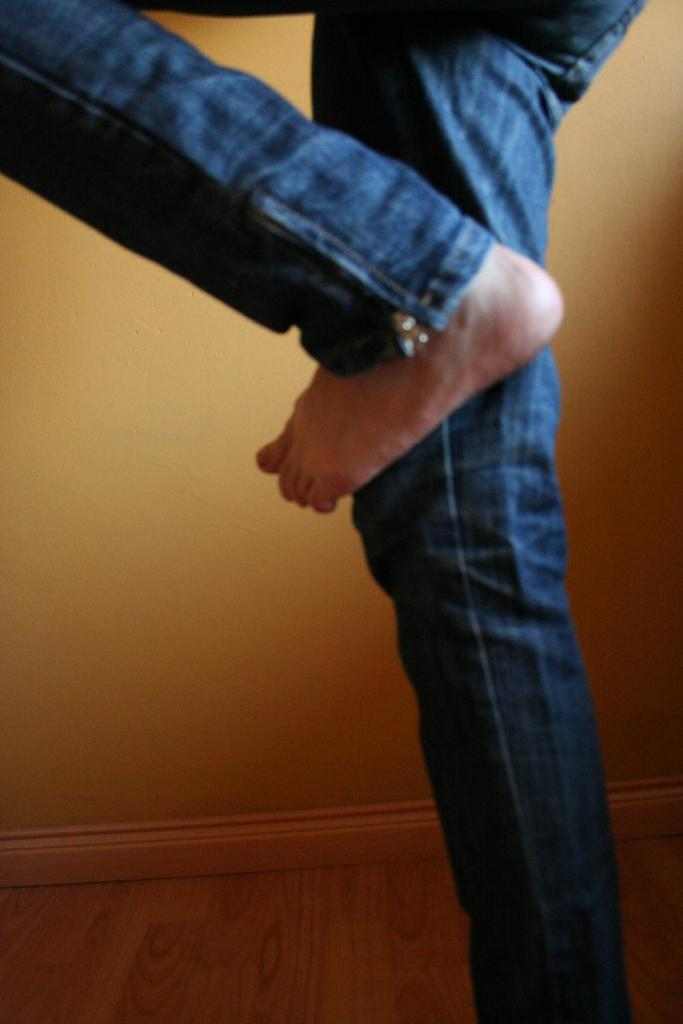What part of a person can be seen in the image? There are legs of a person in the image. What type of clothing is the person wearing? The person is wearing blue jeans. What can be seen in the background of the image? There is a wall in the background of the image. What suggestions does the person's face make in the image? There is no face visible in the image, so it is not possible to determine any suggestions the person might be making. 